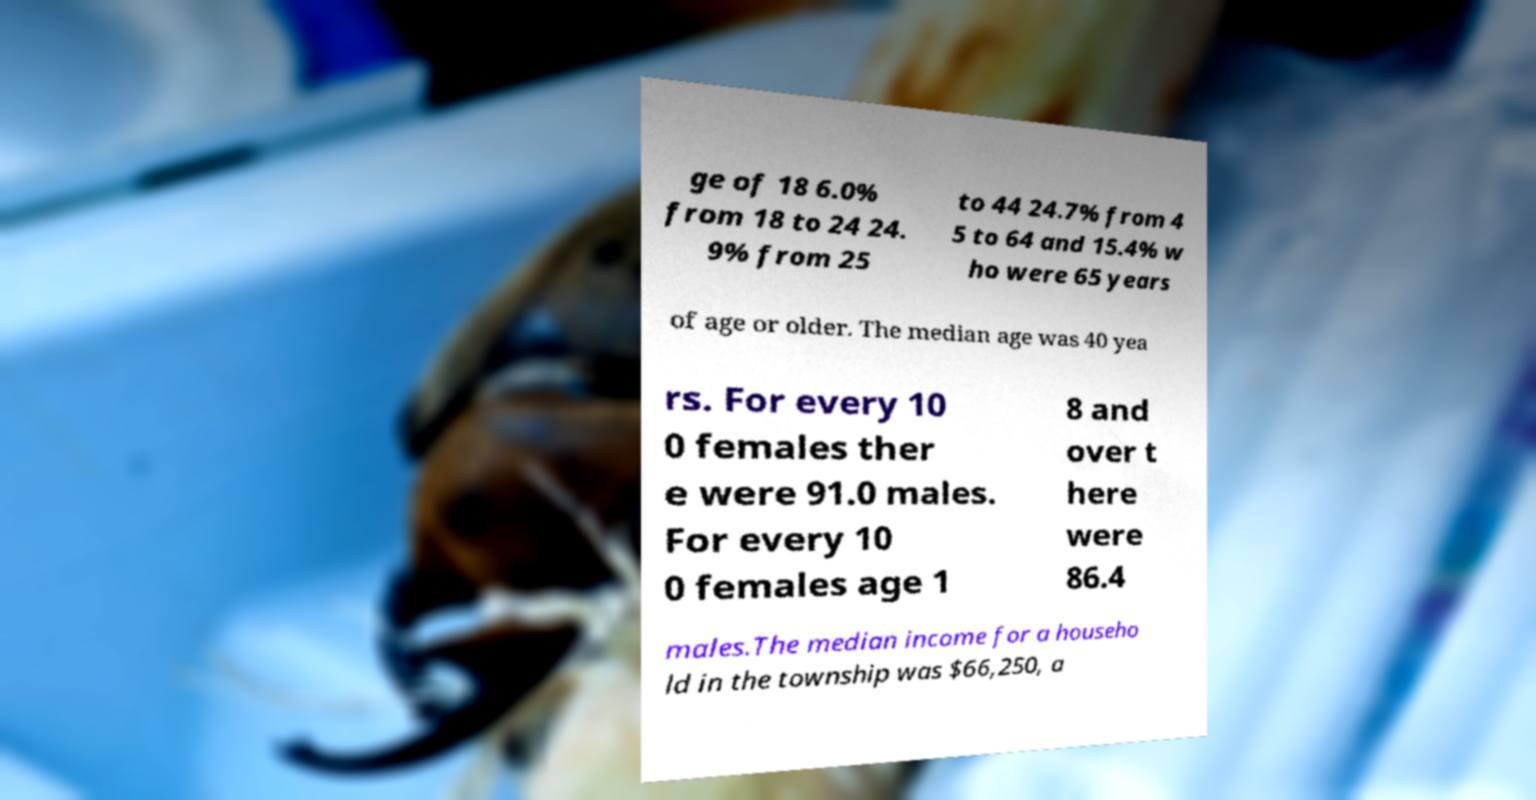Please read and relay the text visible in this image. What does it say? ge of 18 6.0% from 18 to 24 24. 9% from 25 to 44 24.7% from 4 5 to 64 and 15.4% w ho were 65 years of age or older. The median age was 40 yea rs. For every 10 0 females ther e were 91.0 males. For every 10 0 females age 1 8 and over t here were 86.4 males.The median income for a househo ld in the township was $66,250, a 